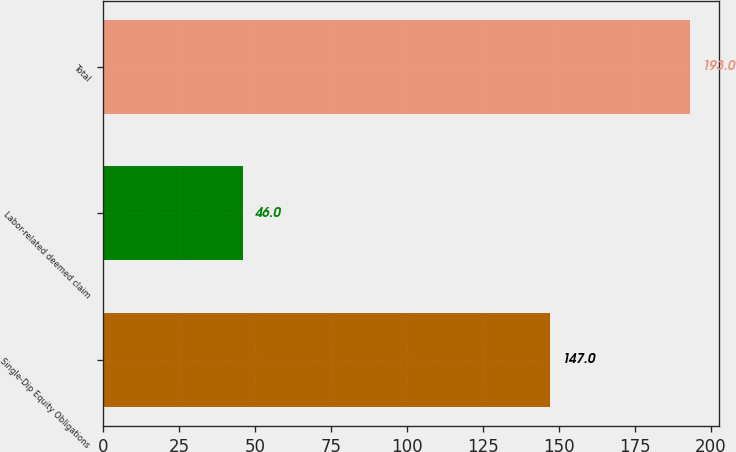Convert chart. <chart><loc_0><loc_0><loc_500><loc_500><bar_chart><fcel>Single-Dip Equity Obligations<fcel>Labor-related deemed claim<fcel>Total<nl><fcel>147<fcel>46<fcel>193<nl></chart> 